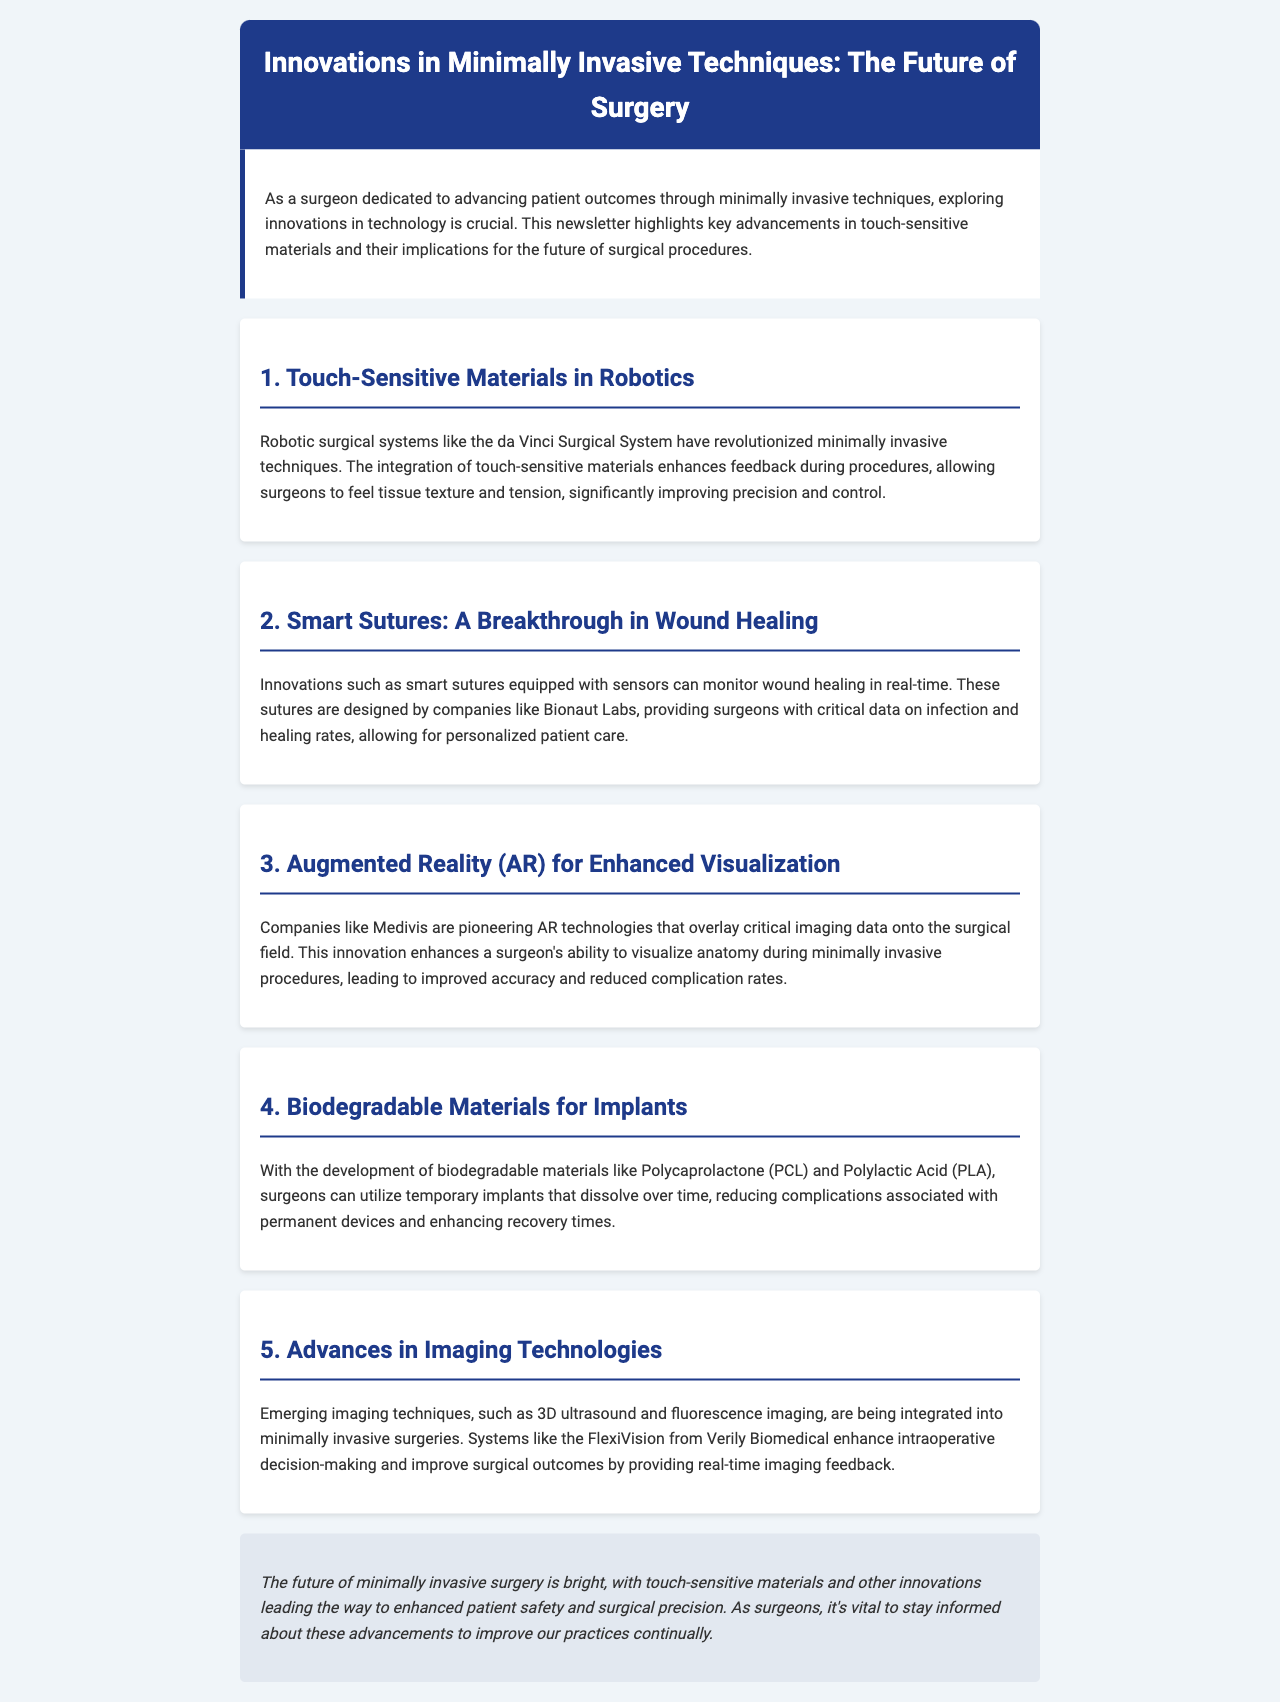What surgical system has revolutionized minimally invasive techniques? The da Vinci Surgical System is mentioned as a revolutionary robotic surgical system in the document.
Answer: da Vinci Surgical System What company is associated with smart sutures? Bionaut Labs is highlighted in the document for their innovations related to smart sutures.
Answer: Bionaut Labs What is the purpose of augmented reality technologies in surgery? The document states that AR technologies enhance a surgeon's ability to visualize anatomy during procedures.
Answer: Enhanced visualization What biodegradable materials are mentioned for implants? Polycaprolactone (PCL) and Polylactic Acid (PLA) are the biodegradable materials discussed in the document.
Answer: PCL and PLA What emerging imaging technique is integrated into minimally invasive surgeries? The document mentions 3D ultrasound as one of the emerging imaging techniques in this context.
Answer: 3D ultrasound How do touch-sensitive materials improve surgical procedures? Touch-sensitive materials enhance feedback during procedures, allowing surgeons to feel tissue texture and tension.
Answer: Feel tissue texture and tension Why is real-time monitoring of wound healing beneficial? It allows for personalized patient care by providing critical data on infection and healing rates.
Answer: Personalized patient care What is the expected outcome of using biodegradable materials? The document indicates that they reduce complications associated with permanent devices and enhance recovery times.
Answer: Reduce complications and enhance recovery times 